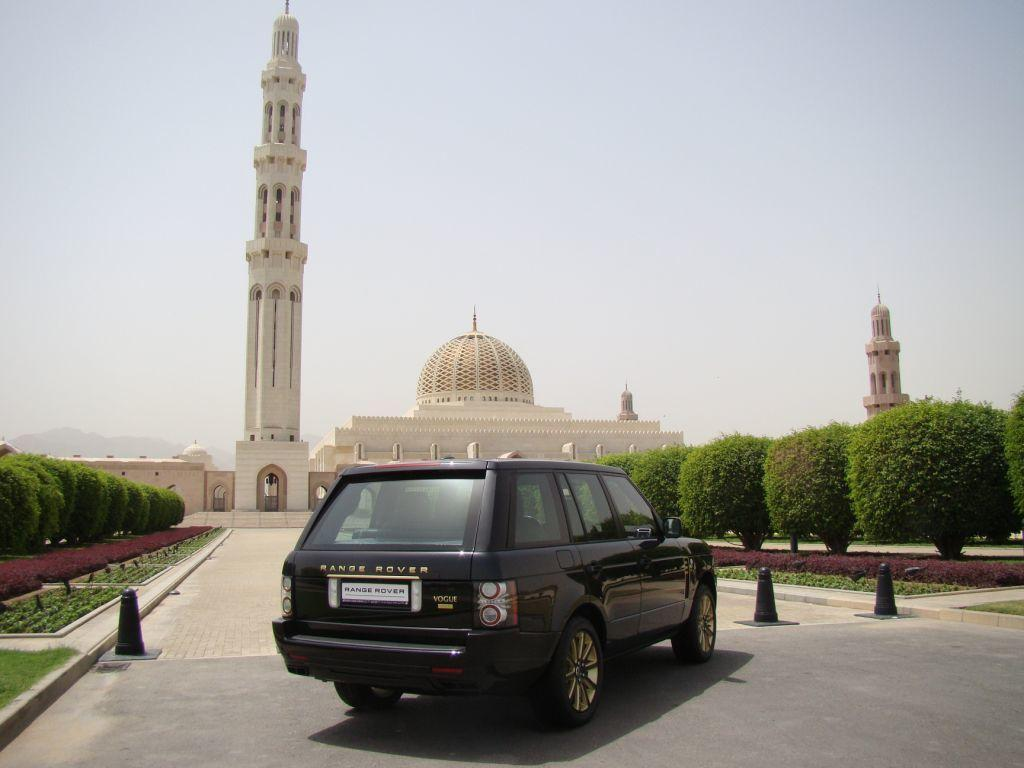Provide a one-sentence caption for the provided image. black range rover sits parked next to a nice builfing. 